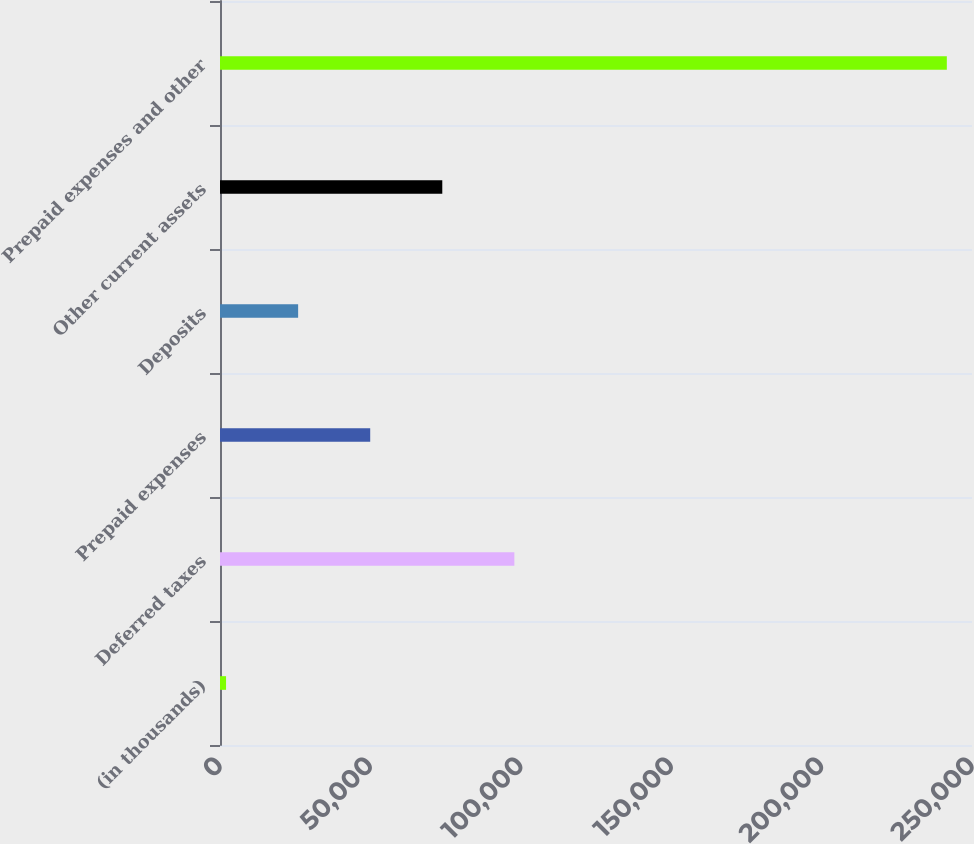Convert chart to OTSL. <chart><loc_0><loc_0><loc_500><loc_500><bar_chart><fcel>(in thousands)<fcel>Deferred taxes<fcel>Prepaid expenses<fcel>Deposits<fcel>Other current assets<fcel>Prepaid expenses and other<nl><fcel>2014<fcel>97860.4<fcel>49937.2<fcel>25975.6<fcel>73898.8<fcel>241630<nl></chart> 